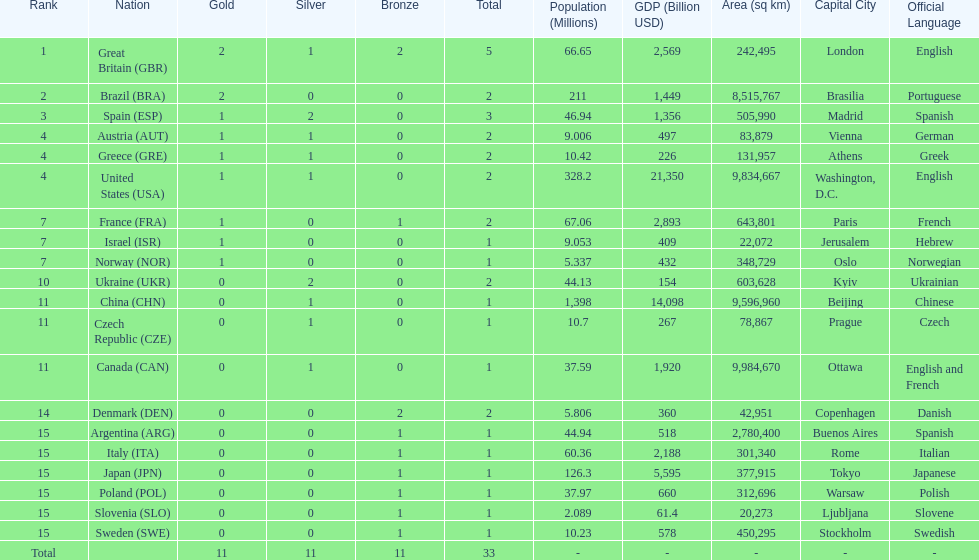How many countries won at least 1 gold and 1 silver medal? 5. 